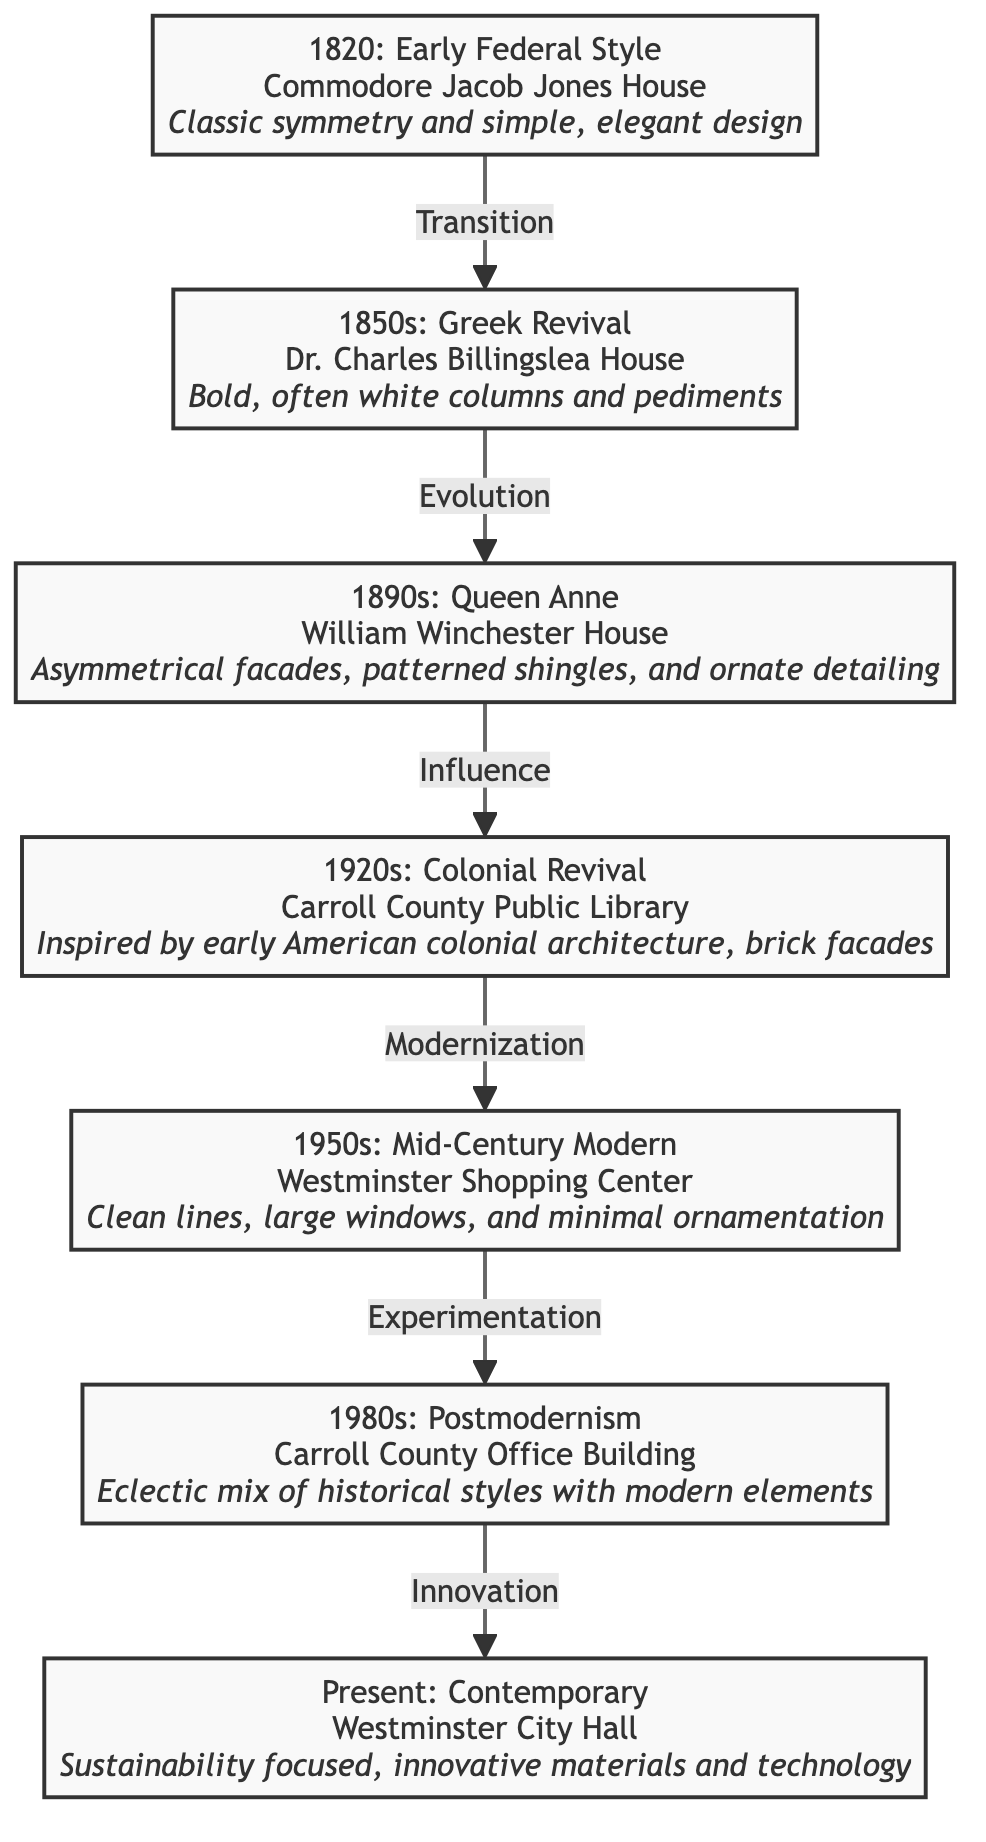What architectural style is represented by the Commodore Jacob Jones House? The diagram identifies the Commodore Jacob Jones House as an example of "Early Federal Style," which is characterized by classic symmetry and simple, elegant design.
Answer: Early Federal Style Which building from the 1890s features asymmetrical facades? According to the diagram, the William Winchester House from the 1890s is the one that features asymmetrical facades, along with patterned shingles and ornate detailing.
Answer: William Winchester House How many architectural styles are shown in this diagram? By counting the distinct nodes in the diagram, it is clear there are seven different architectural styles represented, one for each time period and building listed.
Answer: 7 What was the architectural influence on the Carroll County Public Library? The diagram states that the Carroll County Public Library, built in the 1920s, was influenced by "early American colonial architecture," which can be seen in its brick facades.
Answer: Early American colonial architecture Which building represents the Mid-Century Modern style? The diagram specifically labels the Westminster Shopping Center as the representation of the Mid-Century Modern style, highlighting features like clean lines and large windows.
Answer: Westminster Shopping Center What transition occurs from the 1850s to the 1890s? The transition from the 1850s to the 1890s in the diagram is labeled as "Evolution," indicating a change or development in architectural design during that period.
Answer: Evolution Which architectural style emphasizes sustainability and innovative materials? The Westminster City Hall, marked as the contemporary structure, emphasizes sustainability and innovative materials, as stated in the diagram.
Answer: Contemporary What distinguishes Postmodernism in architecture according to the diagram? The description for the Carroll County Office Building specifies that Postmodernism is characterized by an eclectic mix of historical styles combined with modern elements.
Answer: Eclectic mix of historical styles How does the diagram illustrate the progression of architectural styles? The diagram visually presents a series of nodes connected by arrows, each representing a different architectural style through time, demonstrating the chronological evolution from one to another.
Answer: Chronological evolution 